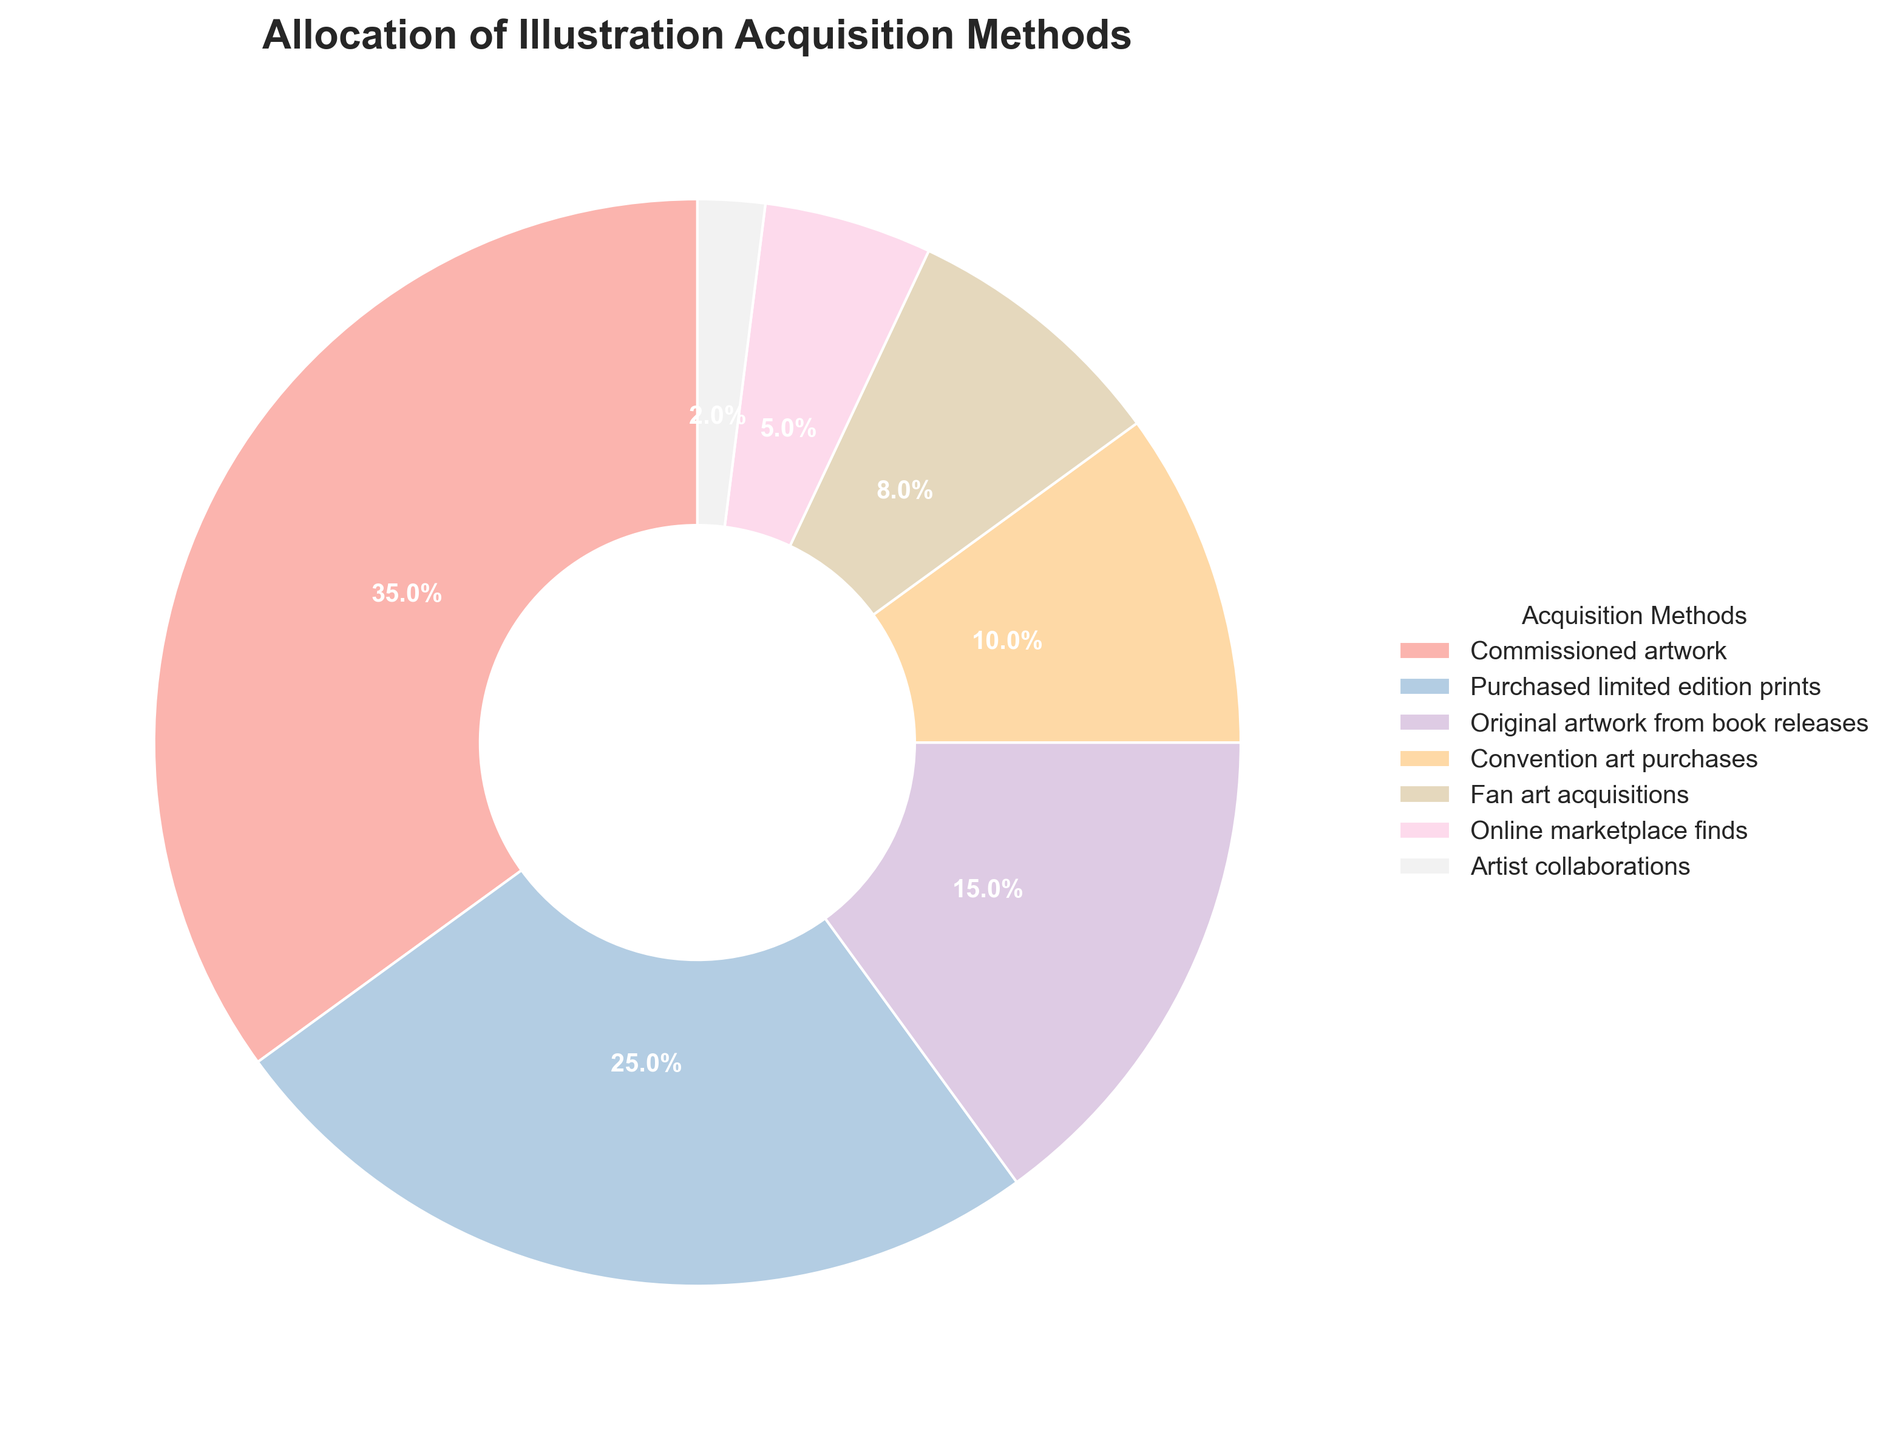Which method of illustration acquisition takes up the largest percentage? By looking at the pie chart, the slice labeled "Commissioned artwork" appears to be the largest. This is confirmed by its 35% label.
Answer: Commissioned artwork What is the difference in percentage between Convention art purchases and Online marketplace finds? Convention art purchases are at 10%, and Online marketplace finds are at 5%. The difference between these percentages is 10% - 5% = 5%.
Answer: 5% How do the combined percentages of Fan art acquisitions and Artist collaborations compare to Purchased limited edition prints? Fan art acquisitions are 8% and Artist collaborations are 2%. Adding these together: 8% + 2% = 10%. Purchased limited edition prints are 25%, so 10% is less than 25%.
Answer: 10% is less Which acquisition method has the third-largest percentage? By examining the pie chart, the third largest segment is "Original artwork from book releases" which has a 15% share, following "Commissioned artwork" and "Purchased limited edition prints".
Answer: Original artwork from book releases What percentage of illustrations come from methods with less than 10% each? The methods with less than 10% each are Fan art acquisitions (8%), Online marketplace finds (5%), and Artist collaborations (2%). Adding these together: 8% + 5% + 2% = 15%.
Answer: 15% Which acquisition method is represented by the second-smallest slice on the pie chart? From the pie chart, the second-smallest slice is labeled "Online marketplace finds" at 5%.
Answer: Online marketplace finds How much more is the percentage of Purchased limited edition prints compared to Original artwork from book releases? Purchased limited edition prints are at 25%, and Original artwork from book releases are at 15%. The difference is 25% - 15% = 10%.
Answer: 10% What are the total percentages of the top three acquisition methods? The top three methods are Commissioned artwork (35%), Purchased limited edition prints (25%), and Original artwork from book releases (15%). Summing them up, 35% + 25% + 15% = 75%.
Answer: 75% Is the percentage of Convention art purchases greater than or equal to Fan art acquisitions? Convention art purchases account for 10%, while Fan art acquisitions account for 8%. Since 10% is greater than 8%, the answer is yes.
Answer: Yes What is the ratio of Commissioned artwork to Artist collaborations in percentage terms? Commissioned artwork is at 35% and Artist collaborations are at 2%. The ratio is 35:2. To simplify, divide both numbers by 2, giving 17.5:1.
Answer: 17.5:1 